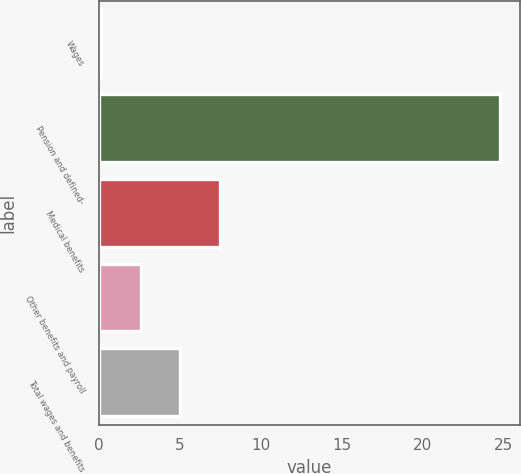Convert chart to OTSL. <chart><loc_0><loc_0><loc_500><loc_500><bar_chart><fcel>Wages<fcel>Pension and defined-<fcel>Medical benefits<fcel>Other benefits and payroll<fcel>Total wages and benefits<nl><fcel>0.1<fcel>24.8<fcel>7.51<fcel>2.57<fcel>5.04<nl></chart> 